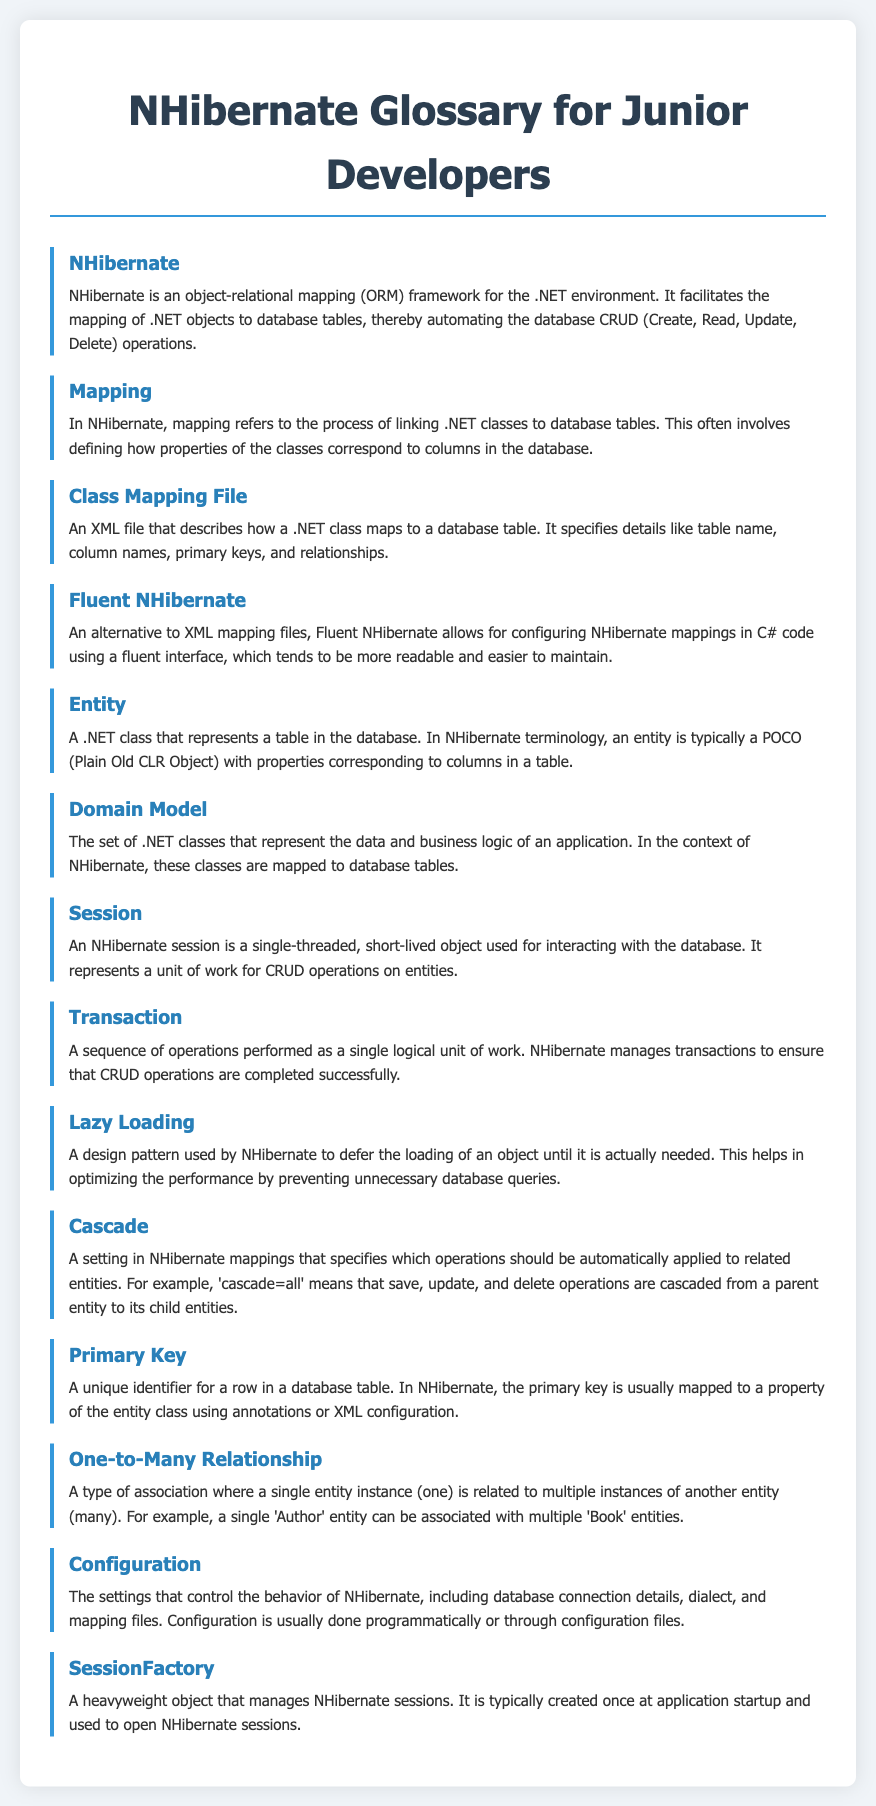What is NHibernate? NHibernate is described as an object-relational mapping (ORM) framework for the .NET environment that automates database CRUD operations.
Answer: An object-relational mapping framework What does mapping refer to in NHibernate? Mapping in NHibernate refers to the process of linking .NET classes to database tables and defining class properties' correspondence to database columns.
Answer: Linking .NET classes to database tables What is a Class Mapping File? A Class Mapping File is defined as an XML file that describes how a .NET class maps to a database table, including details like table name and primary keys.
Answer: An XML file for mapping What is Fluent NHibernate? Fluent NHibernate is presented as an alternative to XML mapping files that allows configuring NHibernate mappings in C# code.
Answer: An alternative to XML mapping files What is an Entity in NHibernate terminology? An Entity is identified as a .NET class that represents a table in the database, typically a Plain Old CLR Object with properties corresponding to columns.
Answer: A .NET class representing a table What does Lazy Loading optimize? Lazy Loading is a design pattern that optimizes performance by deferring the loading of an object until it is actually needed.
Answer: Performance What is the role of a Session in NHibernate? A Session is defined as a single-threaded, short-lived object for interacting with the database, representing a unit of work.
Answer: A unit of work for CRUD operations What is a Primary Key? A Primary Key is described as a unique identifier for a row in a database table, mapped to a property of the entity class.
Answer: A unique identifier What does Cascade define in NHibernate mappings? Cascade specifies which operations should be automatically applied to related entities in NHibernate mappings.
Answer: Automatic operations on related entities What is a SessionFactory? A SessionFactory is identified as a heavyweight object that manages NHibernate sessions, typically created once at application startup.
Answer: A heavyweight object managing sessions 